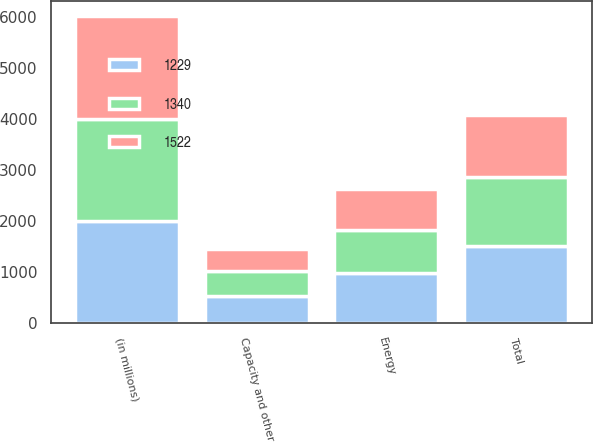Convert chart to OTSL. <chart><loc_0><loc_0><loc_500><loc_500><stacked_bar_chart><ecel><fcel>(in millions)<fcel>Capacity and other<fcel>Energy<fcel>Total<nl><fcel>1229<fcel>2007<fcel>533<fcel>989<fcel>1522<nl><fcel>1340<fcel>2006<fcel>499<fcel>841<fcel>1340<nl><fcel>1522<fcel>2005<fcel>430<fcel>799<fcel>1229<nl></chart> 